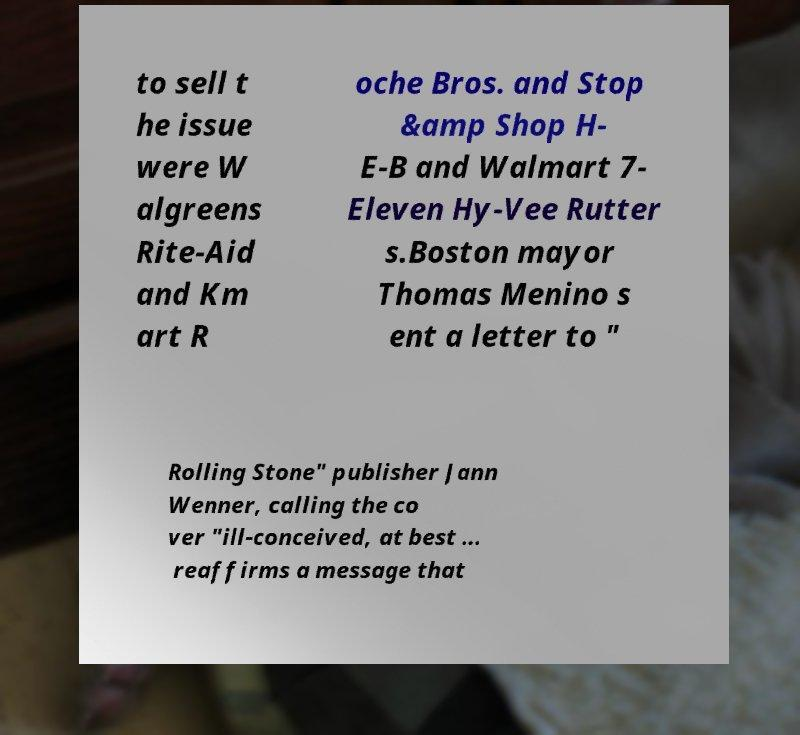Please identify and transcribe the text found in this image. to sell t he issue were W algreens Rite-Aid and Km art R oche Bros. and Stop &amp Shop H- E-B and Walmart 7- Eleven Hy-Vee Rutter s.Boston mayor Thomas Menino s ent a letter to " Rolling Stone" publisher Jann Wenner, calling the co ver "ill-conceived, at best ... reaffirms a message that 